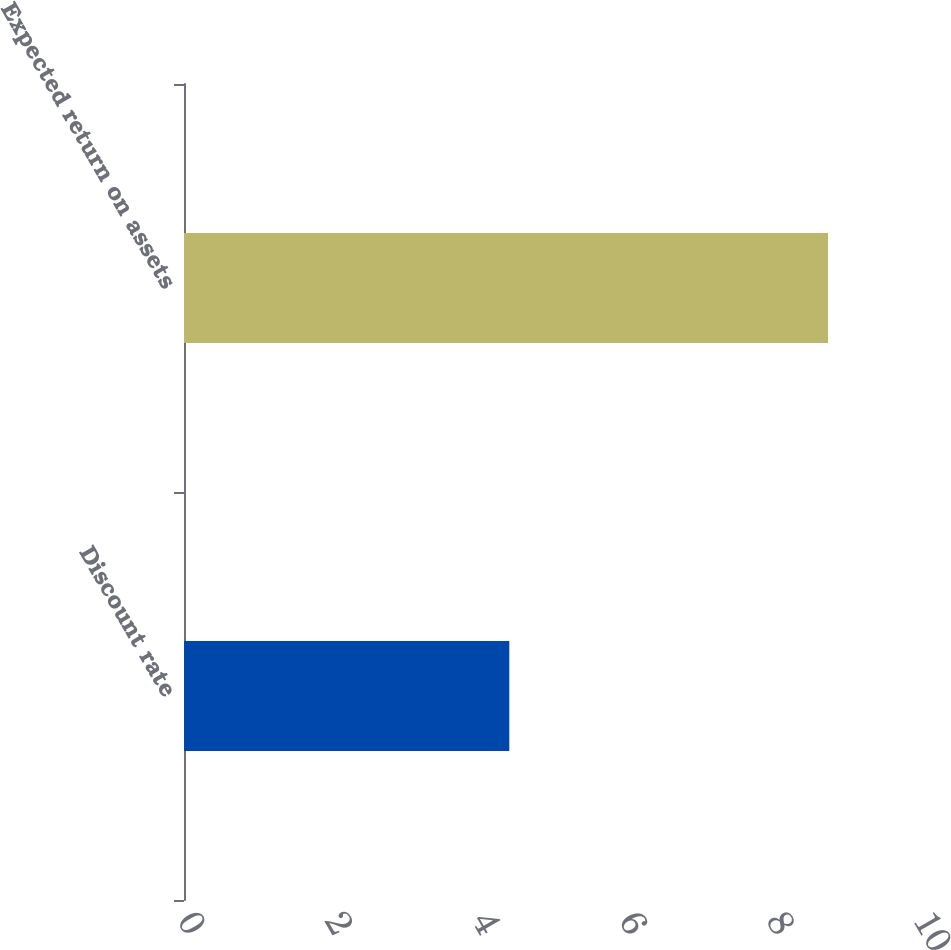Convert chart to OTSL. <chart><loc_0><loc_0><loc_500><loc_500><bar_chart><fcel>Discount rate<fcel>Expected return on assets<nl><fcel>4.42<fcel>8.75<nl></chart> 